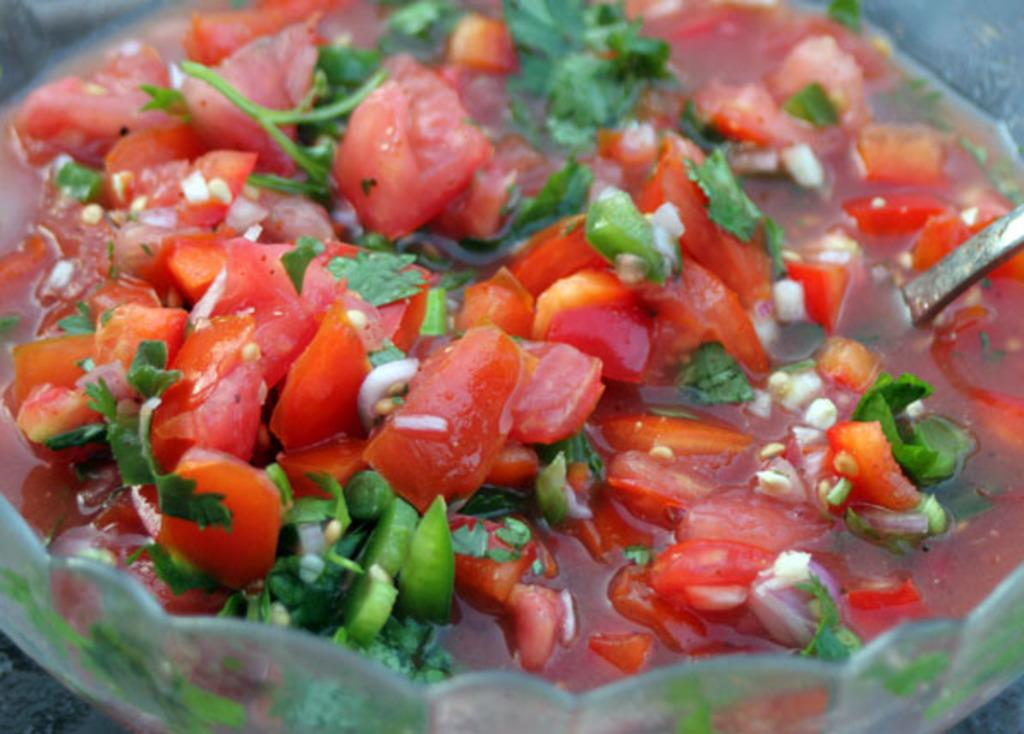What is in the image that can hold food? There is a bowl in the image. What type of food is in the bowl? The bowl contains a food item that contains tomato pieces, leaves, water, and other unspecified items. Can you describe the food item in more detail? The food item contains tomato pieces, leaves, water, and other unspecified items. How does the deer interact with the tub in the image? There is no deer or tub present in the image. How does the food item increase in size over time? The provided facts do not mention any information about the food item increasing in size over time. 